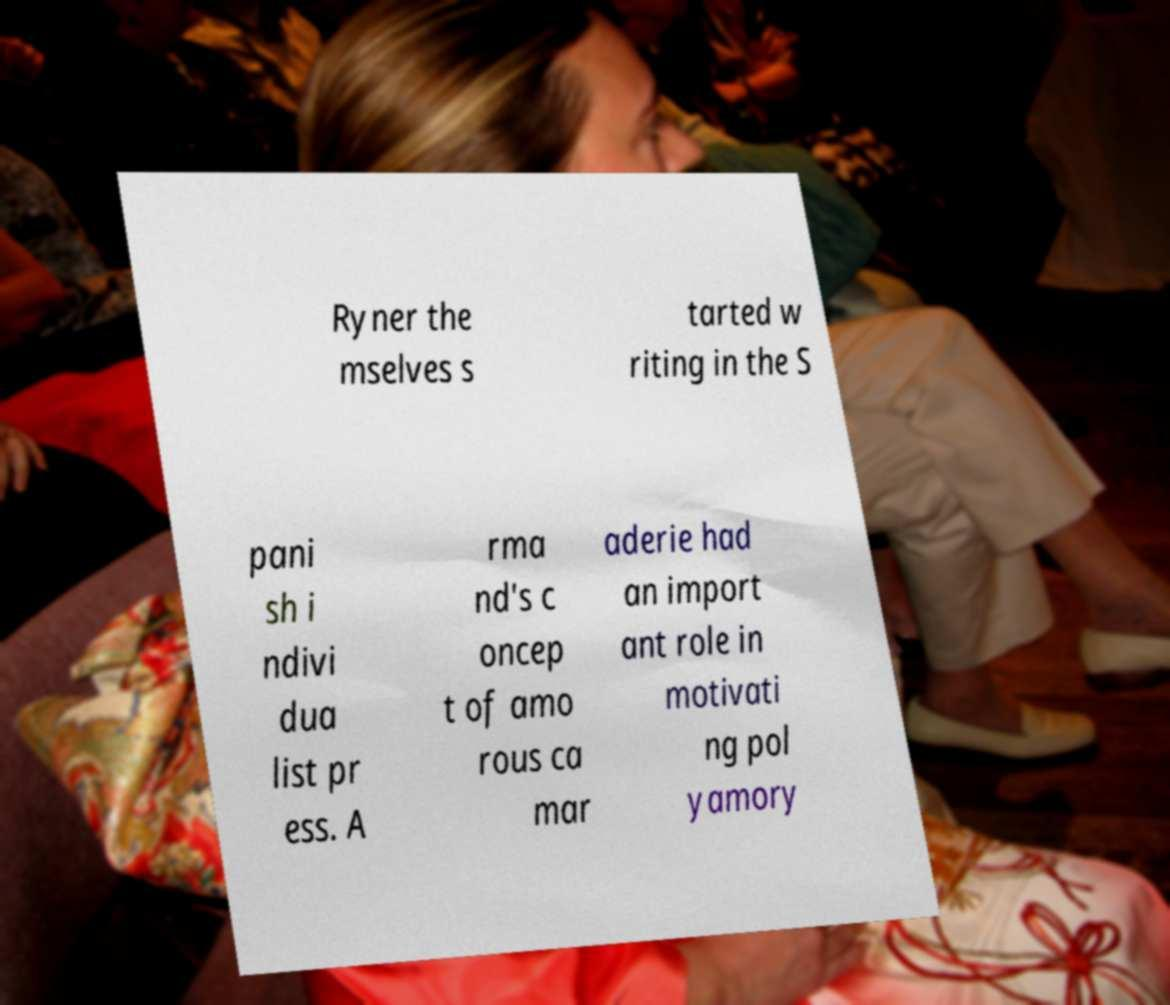I need the written content from this picture converted into text. Can you do that? Ryner the mselves s tarted w riting in the S pani sh i ndivi dua list pr ess. A rma nd's c oncep t of amo rous ca mar aderie had an import ant role in motivati ng pol yamory 